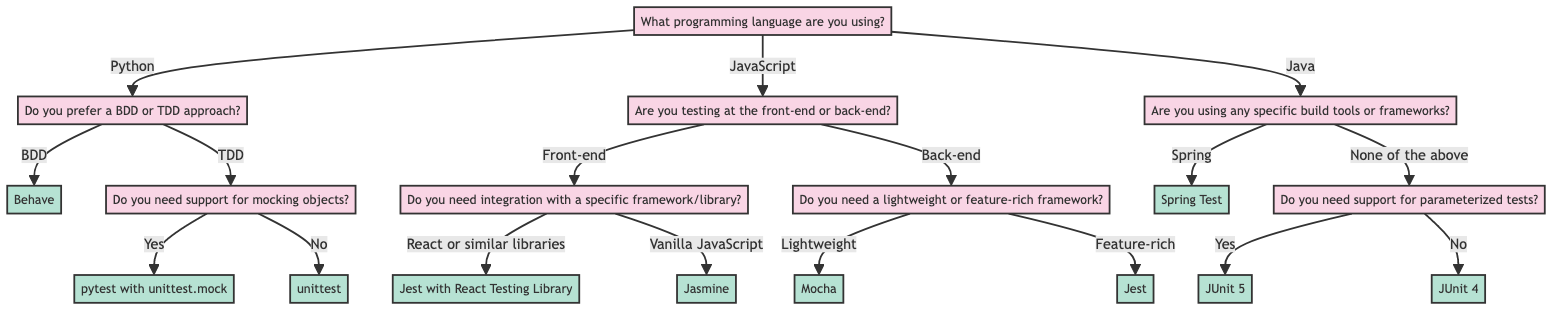What question is posed at the root of the decision tree? The root of the decision tree asks about the programming language being used, which is essential to determine the appropriate unit testing framework later in the decision-making process.
Answer: What programming language are you using? How many programming languages are represented in the diagram? The decision tree outlines three programming languages: Python, JavaScript, and Java, indicating the scope of the decision tree in relation to the unit testing frameworks relevant to these languages.
Answer: Three What is the framework recommended for a BDD approach using Python? The BDD approach using Python leads directly to the recommendation of Behave, which is explicitly stated in the diagram as the framework for that option.
Answer: Behave If a user is testing at the front-end and uses React, which framework should they choose? The decision path indicates that for front-end testing with React or similar libraries, the recommended framework is Jest with React Testing Library, demonstrating a direct correlation between the specific conditions and the framework selection.
Answer: Jest with React Testing Library What support option is provided for Java users who do not use specific build tools? The decision tree denotes that users who are not utilizing any specific build tools are prompted with a question about support for parameterized tests. Responses to this question yield either JUnit 5 or JUnit 4 based on the user's requirement.
Answer: Support for parameterized tests What framework does the decision tree suggest for lightweight back-end JavaScript testing? The pathway for back-end testing indicates that if the user opts for a lightweight framework, the corresponding recommendation is Mocha, which clearly indicates the suitability of this framework for less complex testing scenarios.
Answer: Mocha What does the diagram suggest if the user prefers testing without mock support in Python? Following the path for a TDD approach where no support for mocking is required, the diagram directs users to unittest as the framework best suited for their needs, showcasing a straightforward decision based on user preferences.
Answer: unittest Which framework is related to using the Spring build tool in Java? According to the flow for Java users who are utilizing the Spring build tool, the decision leads directly to Spring Test, indicating a clear and immediate connection between the tool and the recommended testing framework.
Answer: Spring Test What is the final node for users who need support for mocking objects in Python? The pathway delineated for those requiring mock support in a TDD approach ultimately identifies pytest with unittest.mock as the specific framework recommended, concluding this branch of the decision tree.
Answer: pytest with unittest.mock 